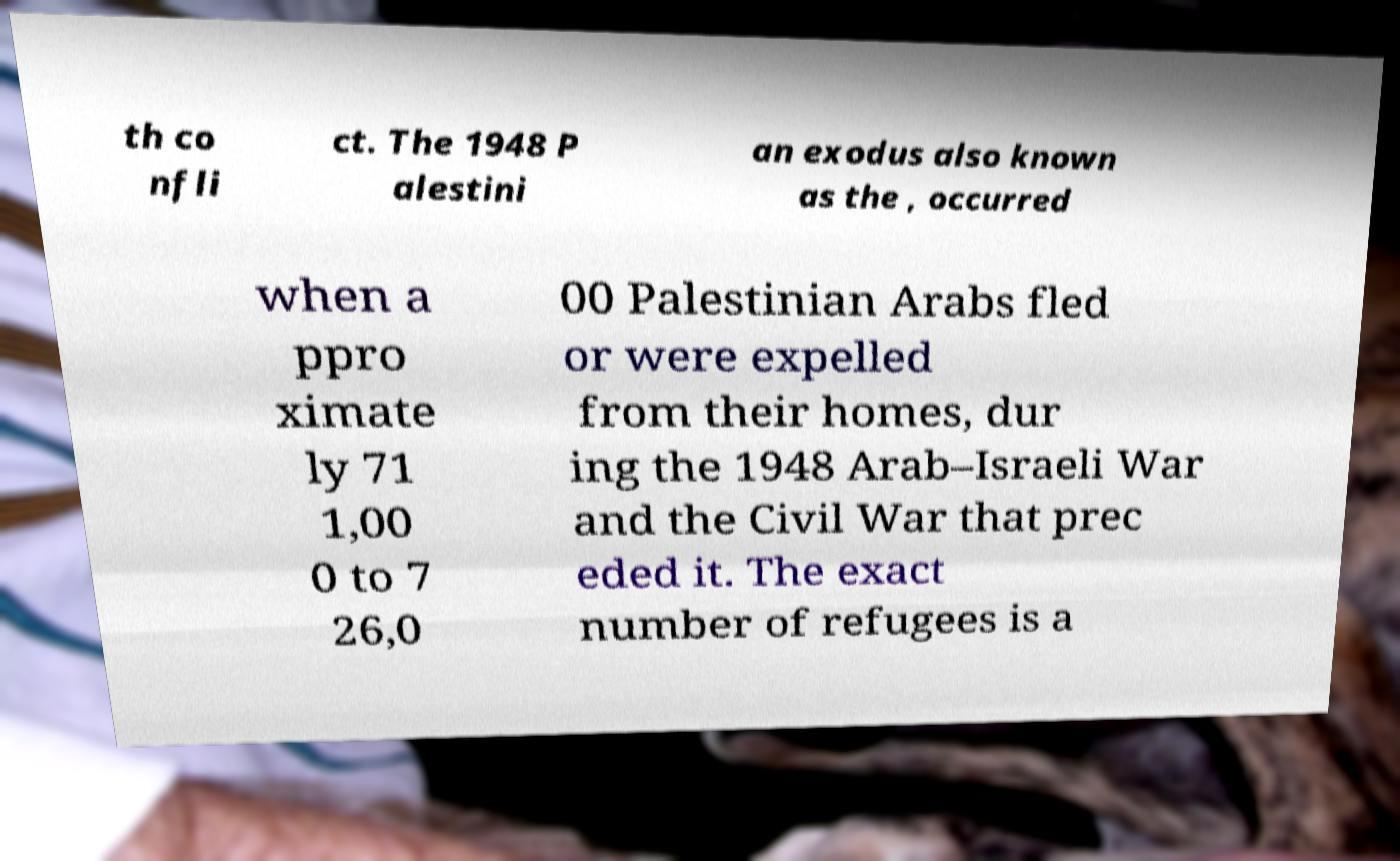For documentation purposes, I need the text within this image transcribed. Could you provide that? th co nfli ct. The 1948 P alestini an exodus also known as the , occurred when a ppro ximate ly 71 1,00 0 to 7 26,0 00 Palestinian Arabs fled or were expelled from their homes, dur ing the 1948 Arab–Israeli War and the Civil War that prec eded it. The exact number of refugees is a 